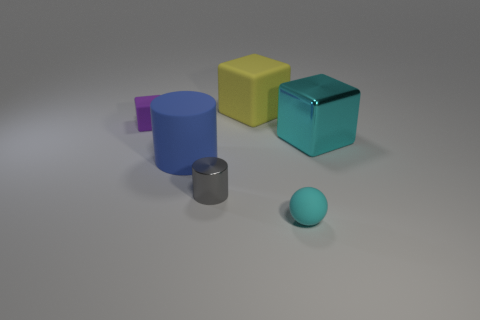There is a metallic thing that is the same color as the ball; what shape is it?
Provide a short and direct response. Cube. What material is the big cyan object that is the same shape as the yellow object?
Your response must be concise. Metal. What size is the ball that is the same color as the large metallic object?
Your answer should be very brief. Small. The yellow matte thing that is the same shape as the large cyan metallic object is what size?
Offer a very short reply. Large. Is there a cyan block?
Make the answer very short. Yes. There is a tiny matte sphere; is it the same color as the shiny object that is to the right of the yellow block?
Offer a terse response. Yes. What is the size of the matte block in front of the large cube to the left of the rubber object that is right of the yellow block?
Keep it short and to the point. Small. What number of tiny things are the same color as the big metallic object?
Offer a very short reply. 1. What number of things are shiny objects or yellow rubber cubes behind the small rubber ball?
Provide a short and direct response. 3. What color is the tiny rubber block?
Offer a terse response. Purple. 